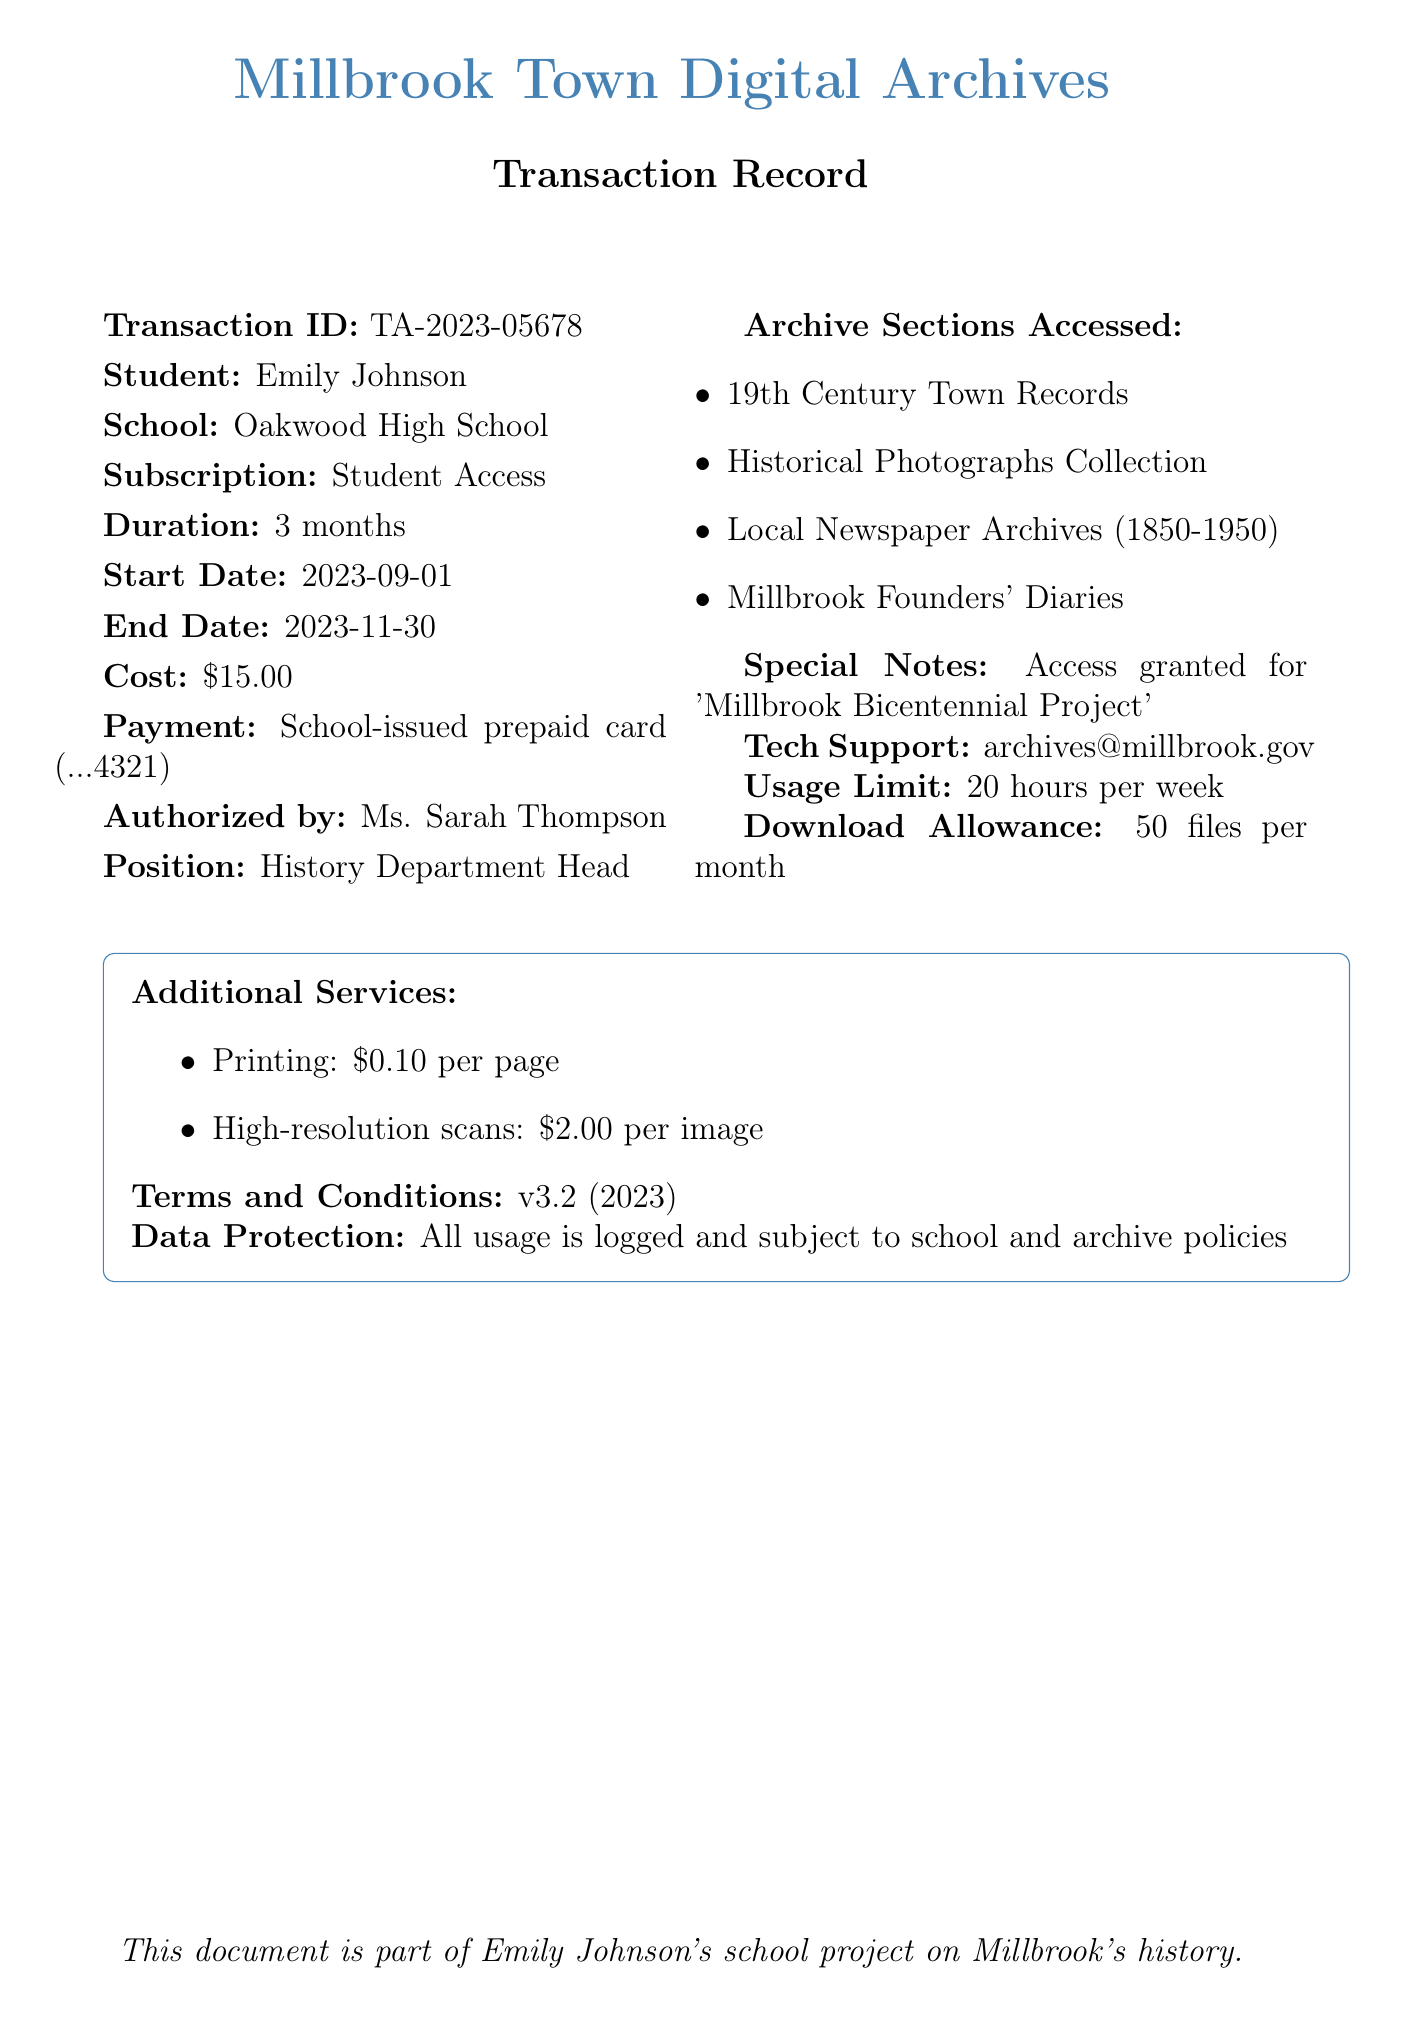What is the transaction ID? The transaction ID is a unique identifier for the transaction, listed in the document as TA-2023-05678.
Answer: TA-2023-05678 Who is the student? The document specifies the student's name as Emily Johnson.
Answer: Emily Johnson What is the subscription duration? The duration of the subscription is stated in the document as 3 months.
Answer: 3 months What is the cost of the subscription? The cost of the subscription is clearly listed in the document as $15.00.
Answer: $15.00 Who authorized the transaction? The document indicates that the transaction was authorized by Ms. Sarah Thompson.
Answer: Ms. Sarah Thompson What is the usage limit per week? The document specifies the usage limit as 20 hours per week.
Answer: 20 hours per week How many files can be downloaded per month? The download allowance in the document states that 50 files can be downloaded per month.
Answer: 50 files per month What project is the access granted for? The document mentions that access was granted for the 'Millbrook Bicentennial Project'.
Answer: Millbrook Bicentennial Project What additional service costs $0.10? The document lists printing as an additional service costing $0.10 per page.
Answer: printing 